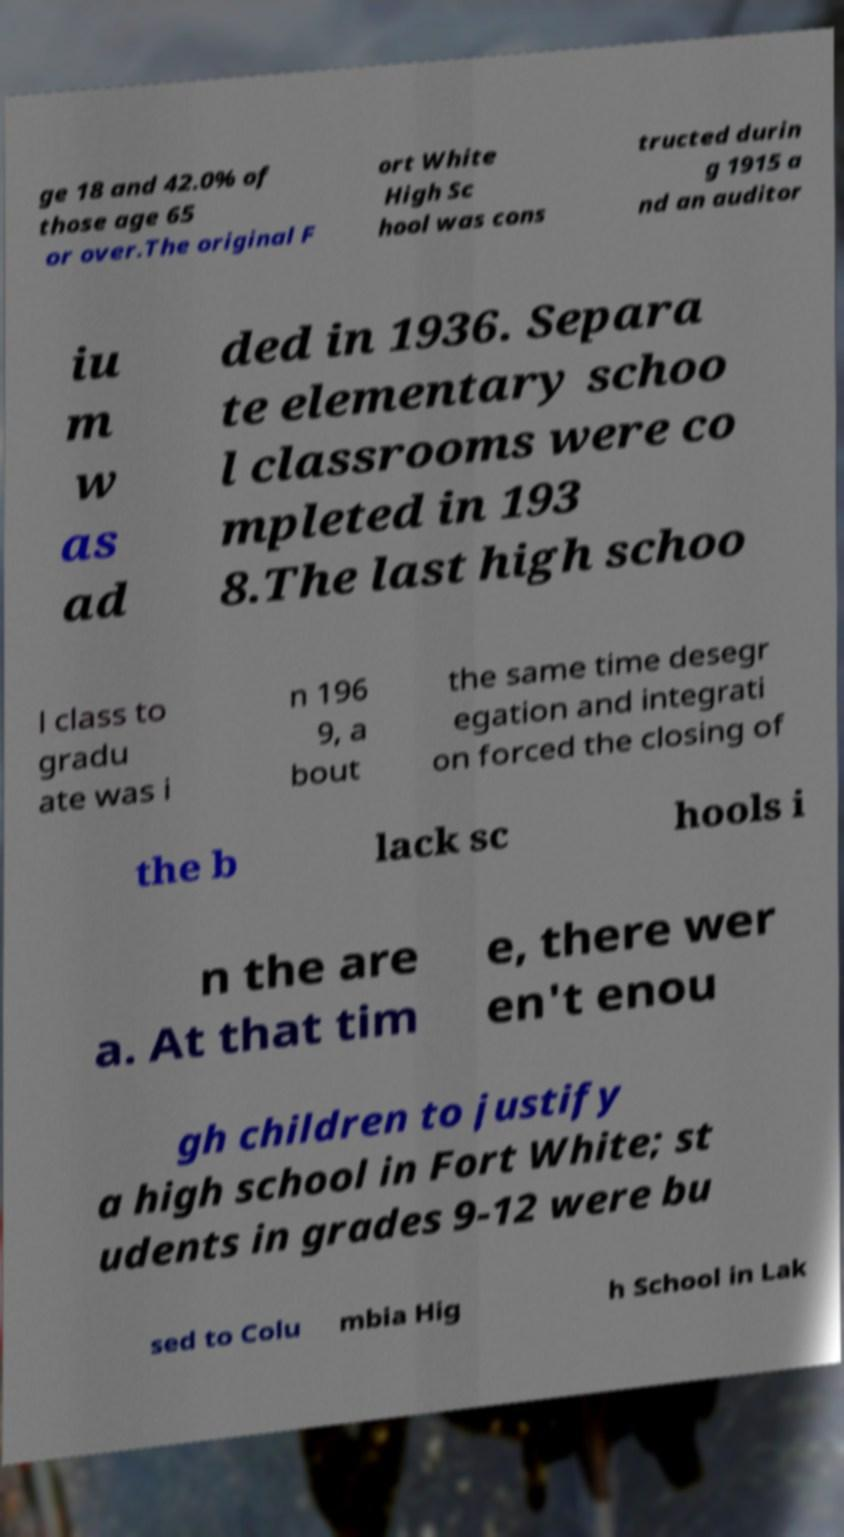Could you assist in decoding the text presented in this image and type it out clearly? ge 18 and 42.0% of those age 65 or over.The original F ort White High Sc hool was cons tructed durin g 1915 a nd an auditor iu m w as ad ded in 1936. Separa te elementary schoo l classrooms were co mpleted in 193 8.The last high schoo l class to gradu ate was i n 196 9, a bout the same time desegr egation and integrati on forced the closing of the b lack sc hools i n the are a. At that tim e, there wer en't enou gh children to justify a high school in Fort White; st udents in grades 9-12 were bu sed to Colu mbia Hig h School in Lak 